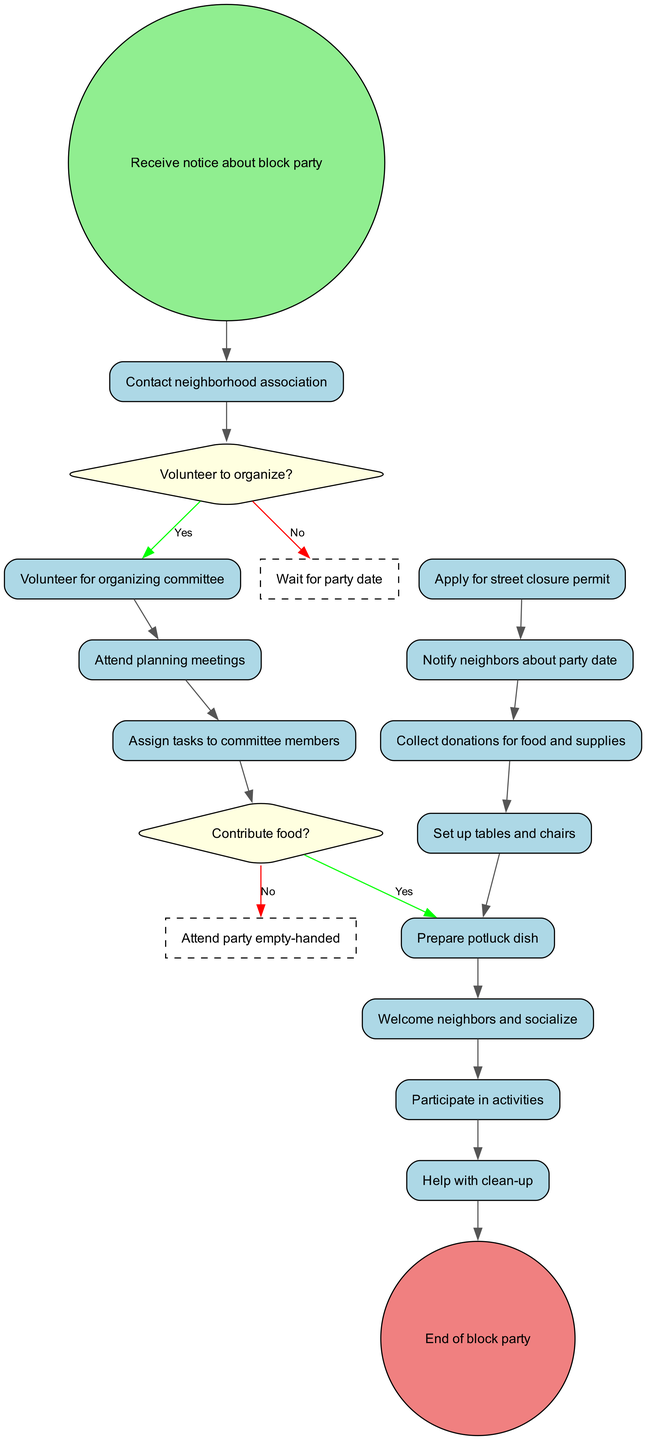What is the initial node in the diagram? The initial node is "Receive notice about block party," which marks the starting point of the activity flow.
Answer: Receive notice about block party How many activities are listed in the diagram? There are twelve activities identified in the activities section of the diagram.
Answer: 12 What are the activities that happen after "Contact neighborhood association"? After "Contact neighborhood association," the next activity is "Volunteer for organizing committee," which follows the initial activity.
Answer: Volunteer for organizing committee What does the decision "Volunteer to organize?" lead to if the answer is 'yes'? If the answer to "Volunteer to organize?" is 'yes,' it leads to the activity "Volunteer for organizing committee." This can be traced through the diagram from the decision node.
Answer: Volunteer for organizing committee How many decisions are present in the diagram? There are two decisions outlined in the decisions section of the diagram: "Volunteer to organize?" and "Contribute food?".
Answer: 2 What is the outcome if someone chooses "no" for both decisions? Choosing "no" for "Volunteer to organize?" leads to "Wait for party date," and choosing "no" for "Contribute food?" results in "Attend party empty-handed," indicating both outputs.
Answer: Wait for party date, Attend party empty-handed Which activity is the last before reaching the final node? The last activity before reaching the final node is "Help with clean-up," which is the penultimate step in the flow leading to the end of the block party.
Answer: Help with clean-up What connects "Set up tables and chairs" to the final node? "Set up tables and chairs" connects to the next activity "Prepare potluck dish," which then leads through the sequence of activities ultimately connecting to the final node.
Answer: Prepare potluck dish What are the colors used to represent activities and decisions in this diagram? Activities are represented with light blue rectangles, while decisions are shown with light yellow diamonds. This color-coding helps differentiate the types of nodes.
Answer: Light blue for activities, light yellow for decisions 